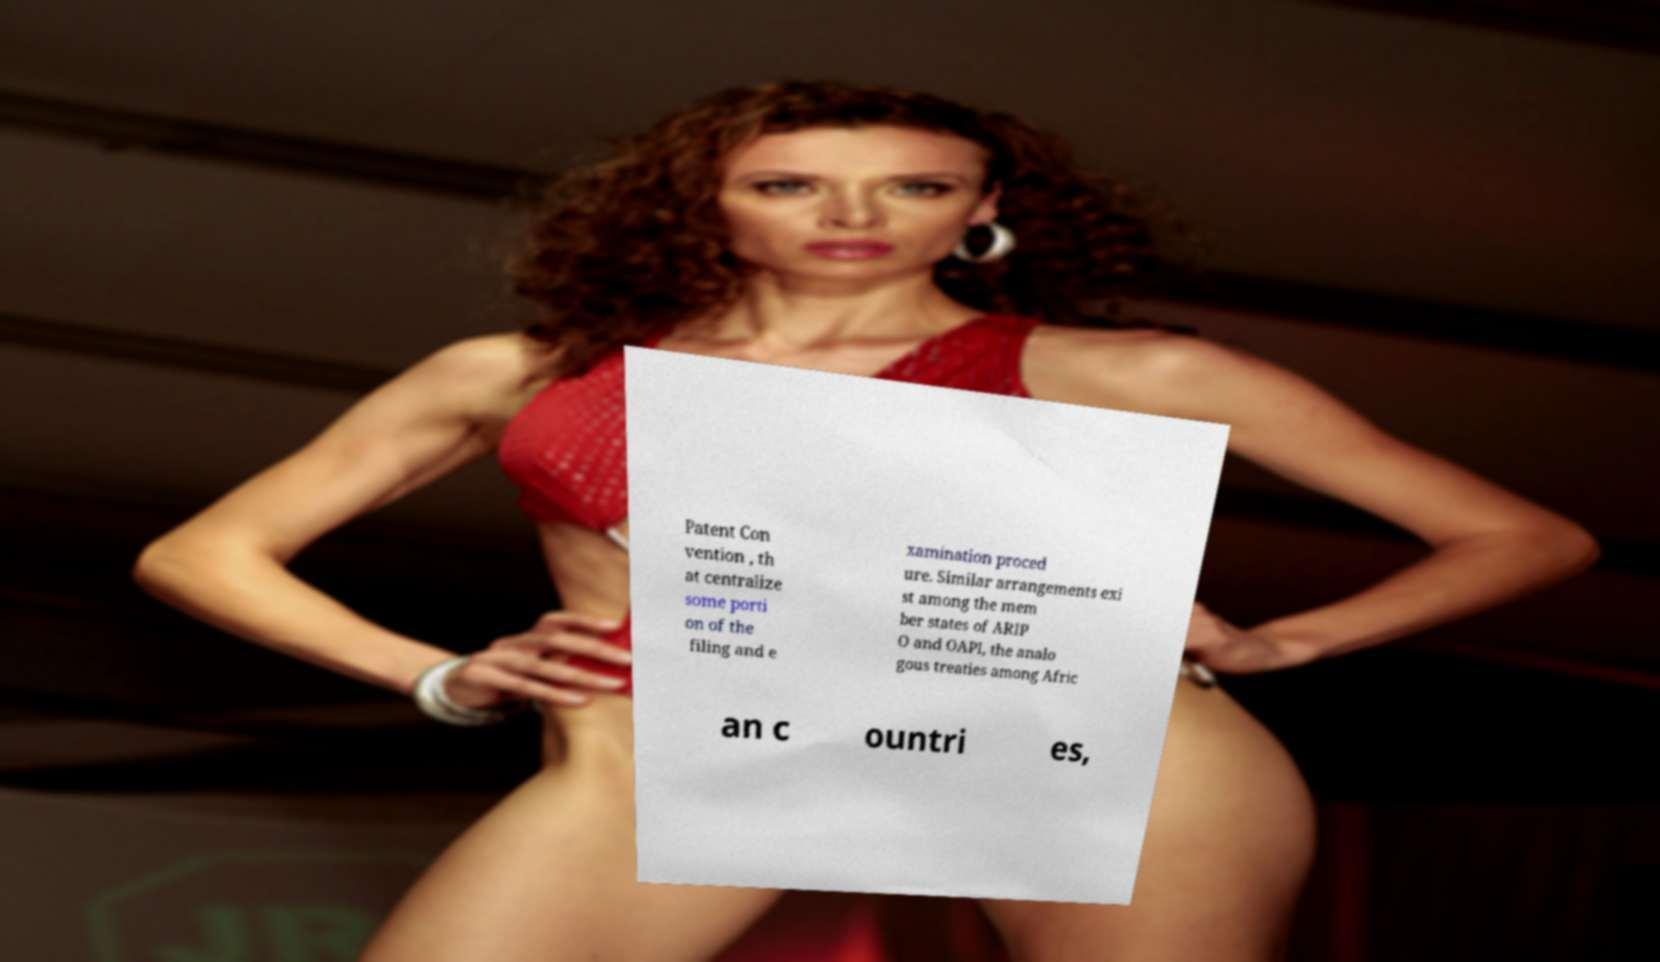Could you assist in decoding the text presented in this image and type it out clearly? Patent Con vention , th at centralize some porti on of the filing and e xamination proced ure. Similar arrangements exi st among the mem ber states of ARIP O and OAPI, the analo gous treaties among Afric an c ountri es, 